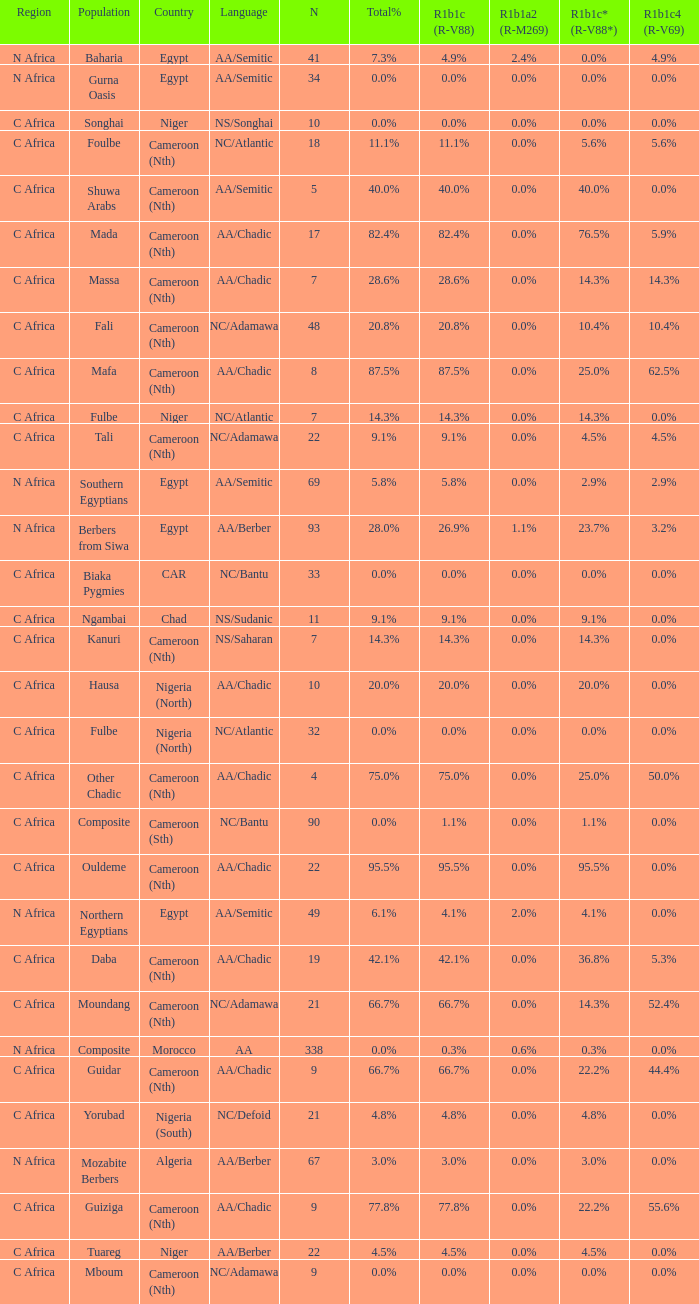How many n are listed for berbers from siwa? 1.0. 